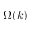Convert formula to latex. <formula><loc_0><loc_0><loc_500><loc_500>\Omega ( k )</formula> 